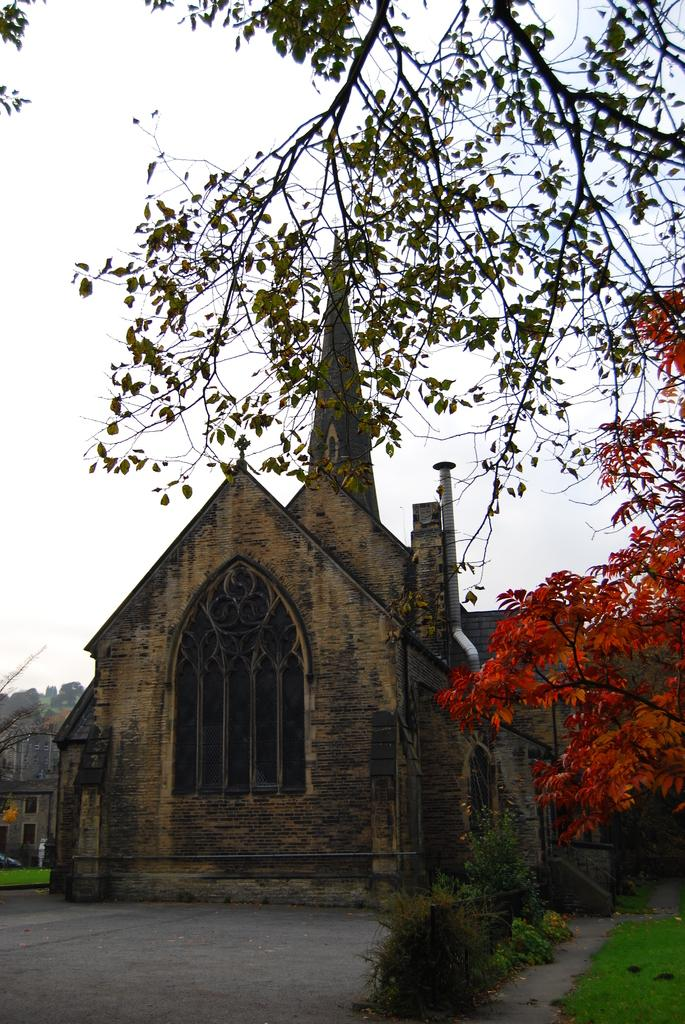What type of structures can be seen in the image? There are buildings in the image. What is present on the ground in the image? There are bushes and grass on the ground in the image. What type of vegetation is present in the image? There are trees in the image. What is visible in the sky in the image? The sky is clear in the image. What is the weight of the feather on the bed in the image? There is no bed or feather present in the image; it only contains buildings, bushes, grass, trees, and a clear sky. 